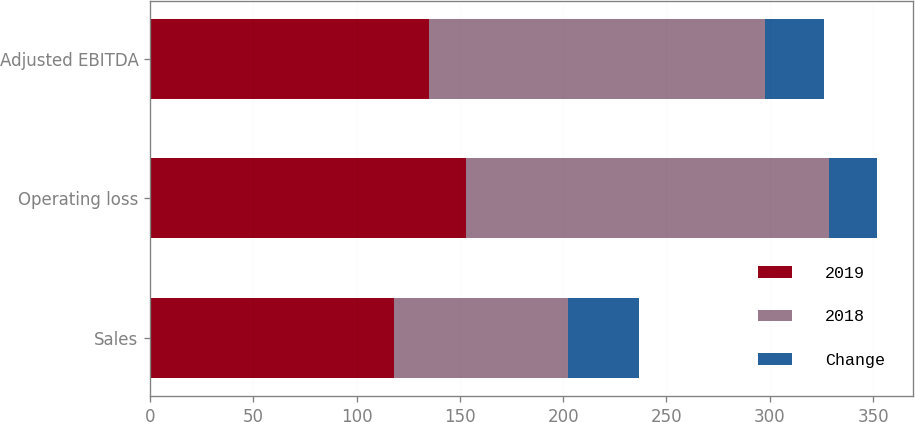<chart> <loc_0><loc_0><loc_500><loc_500><stacked_bar_chart><ecel><fcel>Sales<fcel>Operating loss<fcel>Adjusted EBITDA<nl><fcel>2019<fcel>118.3<fcel>152.8<fcel>134.8<nl><fcel>2018<fcel>84<fcel>176<fcel>163.1<nl><fcel>Change<fcel>34.3<fcel>23.2<fcel>28.3<nl></chart> 